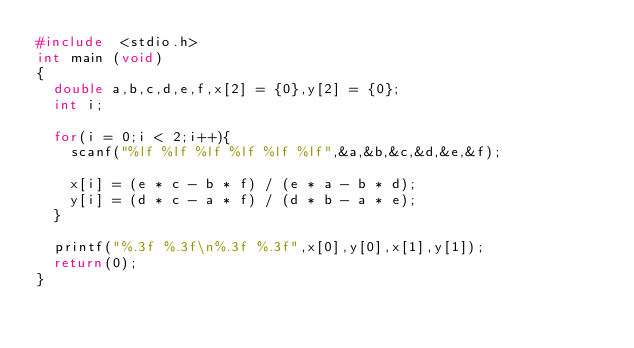<code> <loc_0><loc_0><loc_500><loc_500><_C_>#include  <stdio.h>
int main (void)
{
	double a,b,c,d,e,f,x[2] = {0},y[2] = {0};	
	int i;
	
	for(i = 0;i < 2;i++){
		scanf("%lf %lf %lf %lf %lf %lf",&a,&b,&c,&d,&e,&f);
	
		x[i] = (e * c - b * f) / (e * a - b * d);
		y[i] = (d * c - a * f) / (d * b - a * e);
	}

	printf("%.3f %.3f\n%.3f %.3f",x[0],y[0],x[1],y[1]);
	return(0);
}</code> 